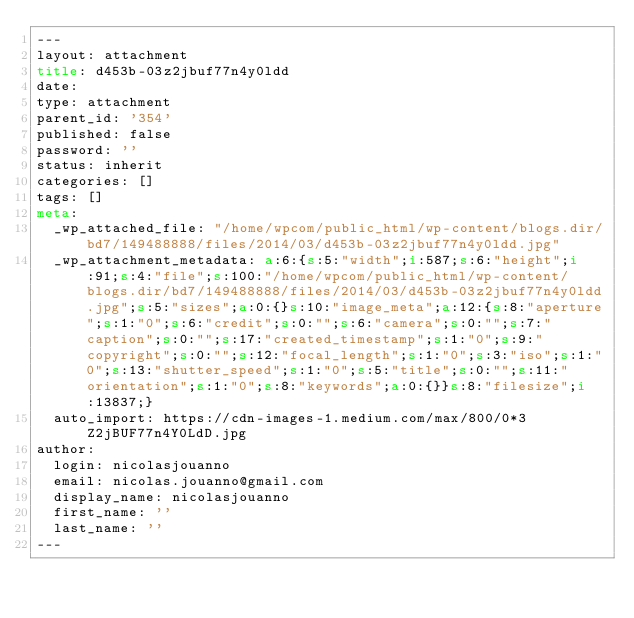Convert code to text. <code><loc_0><loc_0><loc_500><loc_500><_HTML_>---
layout: attachment
title: d453b-03z2jbuf77n4y0ldd
date: 
type: attachment
parent_id: '354'
published: false
password: ''
status: inherit
categories: []
tags: []
meta:
  _wp_attached_file: "/home/wpcom/public_html/wp-content/blogs.dir/bd7/149488888/files/2014/03/d453b-03z2jbuf77n4y0ldd.jpg"
  _wp_attachment_metadata: a:6:{s:5:"width";i:587;s:6:"height";i:91;s:4:"file";s:100:"/home/wpcom/public_html/wp-content/blogs.dir/bd7/149488888/files/2014/03/d453b-03z2jbuf77n4y0ldd.jpg";s:5:"sizes";a:0:{}s:10:"image_meta";a:12:{s:8:"aperture";s:1:"0";s:6:"credit";s:0:"";s:6:"camera";s:0:"";s:7:"caption";s:0:"";s:17:"created_timestamp";s:1:"0";s:9:"copyright";s:0:"";s:12:"focal_length";s:1:"0";s:3:"iso";s:1:"0";s:13:"shutter_speed";s:1:"0";s:5:"title";s:0:"";s:11:"orientation";s:1:"0";s:8:"keywords";a:0:{}}s:8:"filesize";i:13837;}
  auto_import: https://cdn-images-1.medium.com/max/800/0*3Z2jBUF77n4Y0LdD.jpg
author:
  login: nicolasjouanno
  email: nicolas.jouanno@gmail.com
  display_name: nicolasjouanno
  first_name: ''
  last_name: ''
---

</code> 